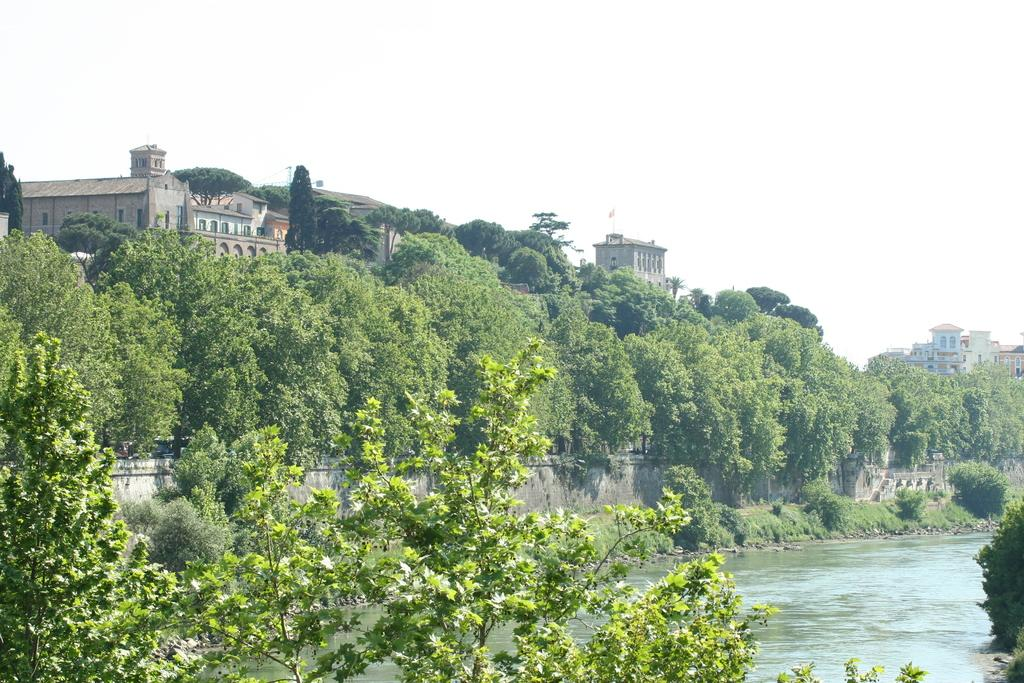What is one of the natural elements visible in the image? There is water visible in the image. What type of vegetation can be seen in the image? There are trees and plants in the image. What type of man-made structures are present in the image? There is a wall and many buildings in the image. What part of the natural environment is visible in the background of the image? The sky is visible in the background of the image. What type of peace offering is being made by the base in the image? There is no peace offering or base present in the image. 